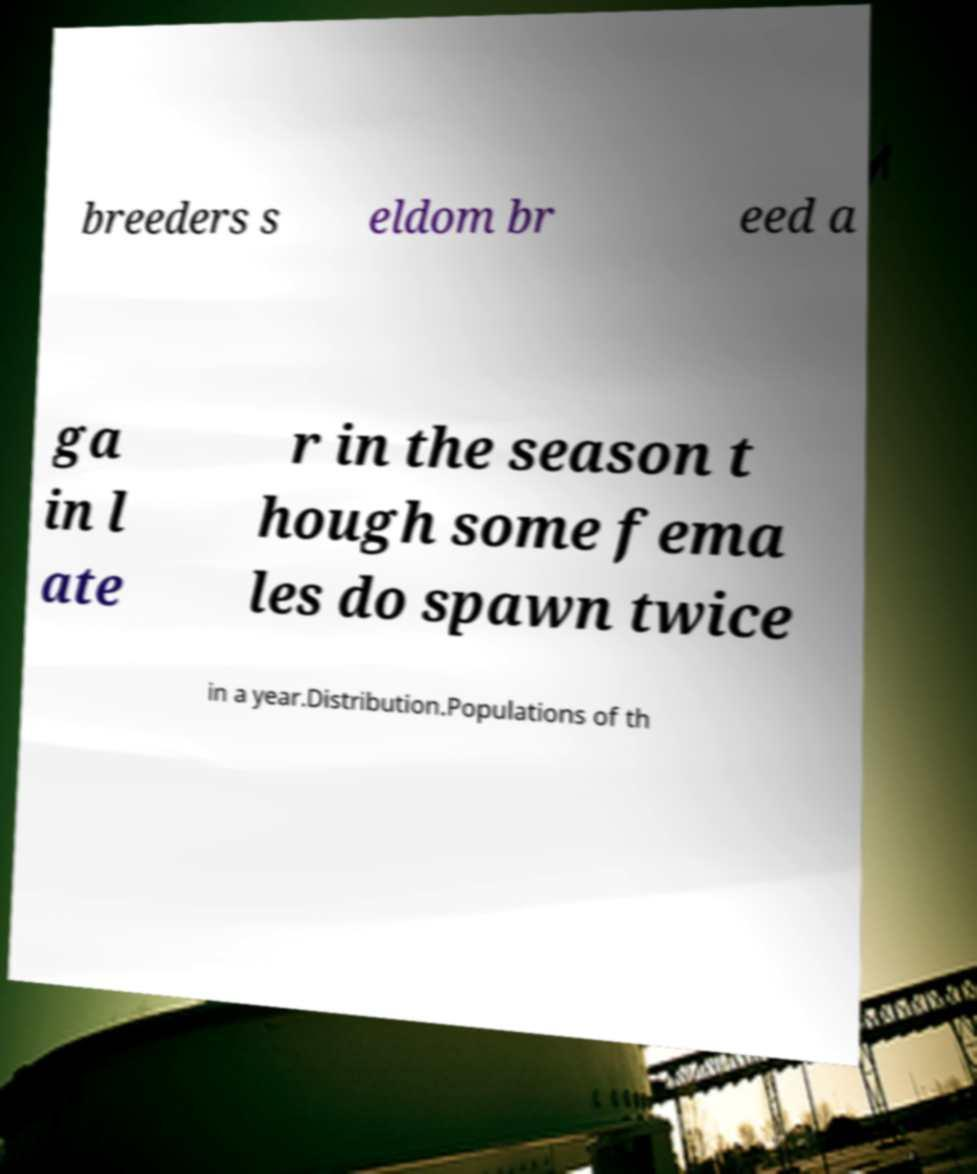Please identify and transcribe the text found in this image. breeders s eldom br eed a ga in l ate r in the season t hough some fema les do spawn twice in a year.Distribution.Populations of th 